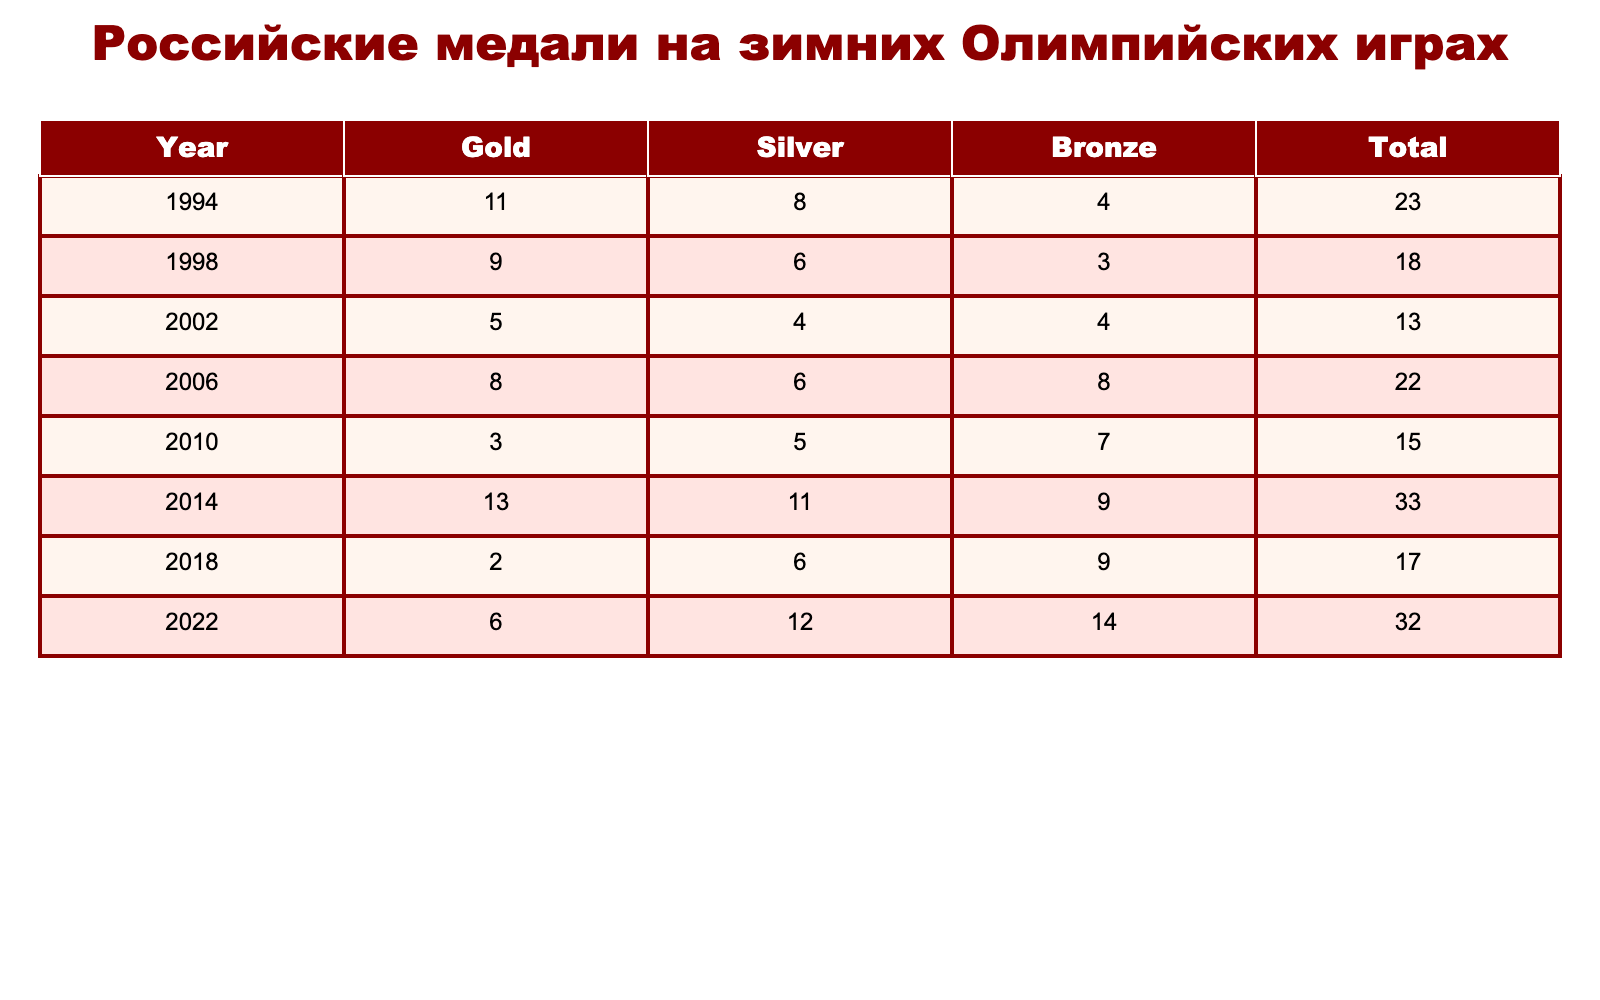What's the total number of medals won by Russia in the 2014 Winter Olympics? Referring to the table, the row for 2014 shows a total of 33 medals.
Answer: 33 How many gold medals did Russian athletes win in 1998? Looking at the 1998 row, it displays 9 gold medals.
Answer: 9 In which year did Russia win the highest number of silver medals? The silver medal counts are 8 (1994), 6 (1998), 4 (2002), 6 (2006), 5 (2010), 11 (2014), 6 (2018), and 12 (2022). The highest is 12 in 2022.
Answer: 2022 What is the average number of bronze medals won across all Winter Olympics? I will sum the bronze medal counts: 4 + 3 + 4 + 8 + 7 + 9 + 9 + 14 = 58. Then, divide by 8 (the number of Olympics) which gives 58/8 = 7.25.
Answer: 7.25 Did Russia win more gold medals in 2006 than in 2010? In 2006, Russia won 8 gold medals; in 2010, they won 3. Since 8 > 3, the statement is true.
Answer: Yes What is the total number of medals Russia won in the years 2010 and 2018 combined? The total medals for 2010 are 15 and for 2018 are 17. Adding these gives 15 + 17 = 32.
Answer: 32 How many silver medals did Russia win in the Olympics with the lowest total medal count? The lowest total medal count is 13 in 2002, which corresponds to 4 silver medals.
Answer: 4 Which Winter Olympics year had the highest combined medal count, and what was that count? Checking the total counts, 2014 has the highest at 33 medals, as seen from the table.
Answer: 33 